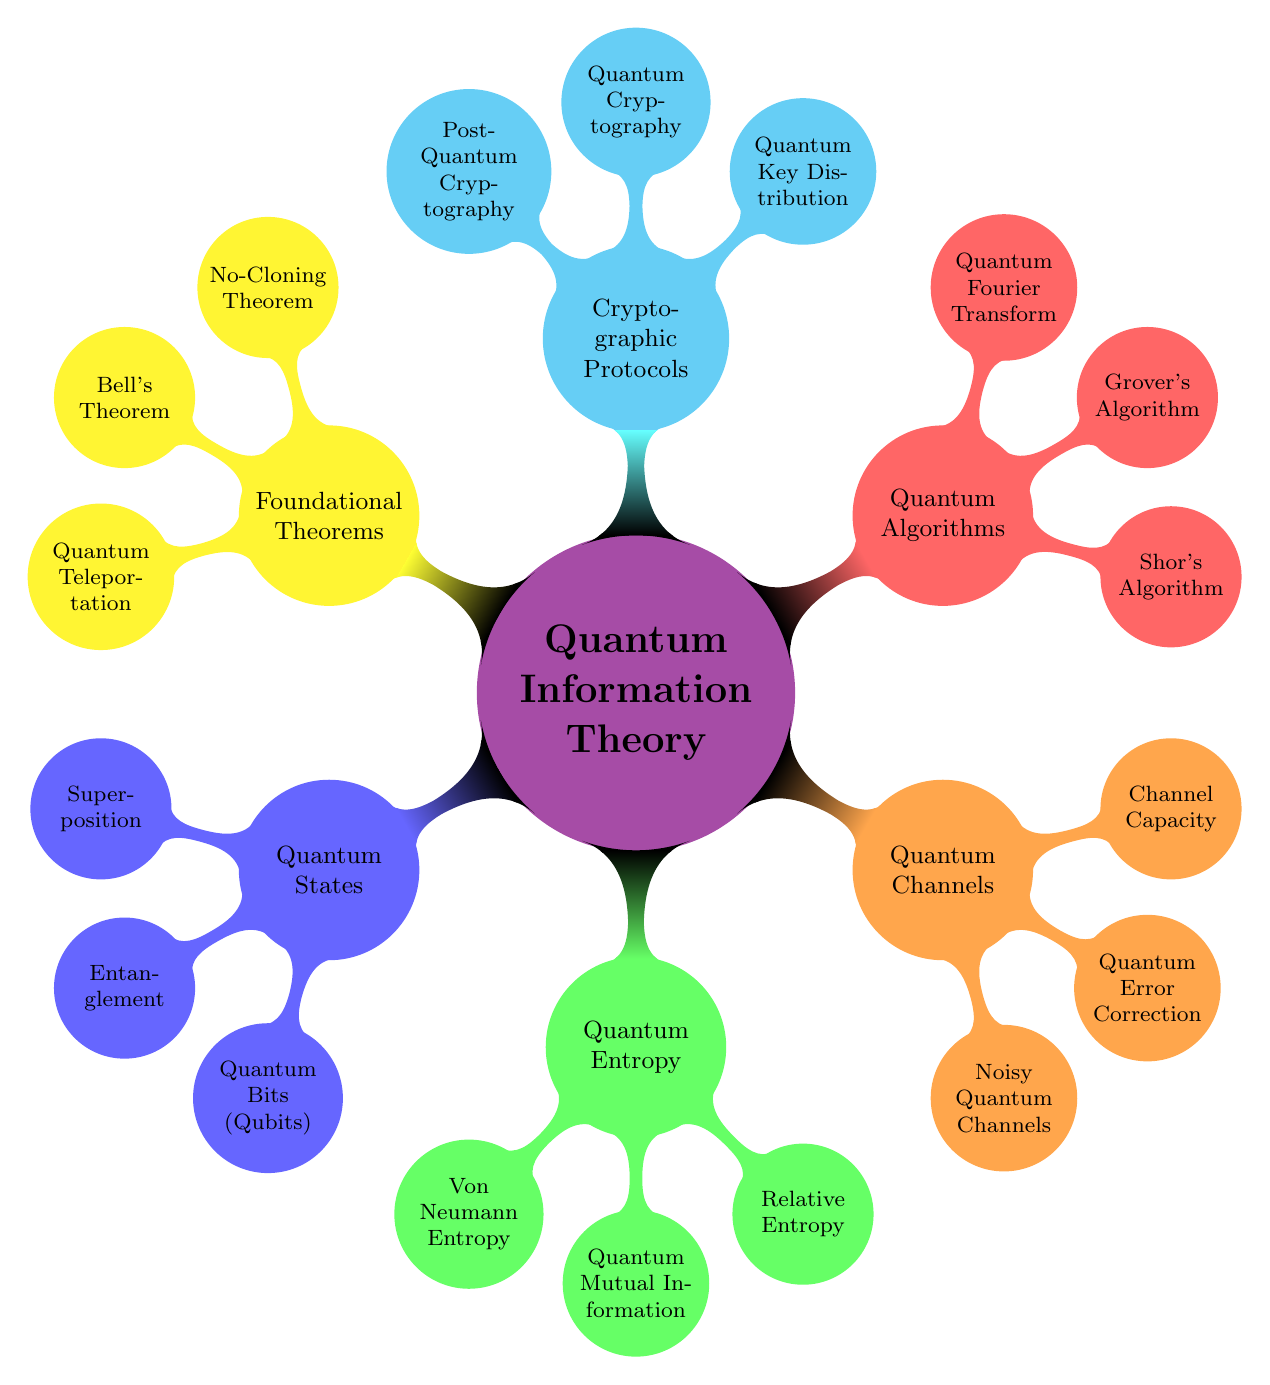What is the main topic of the diagram? The main topic is clearly labeled at the top center of the diagram, which is "Quantum Information Theory".
Answer: Quantum Information Theory How many child nodes does the "Quantum Algorithms" node have? By counting the immediate children of the "Quantum Algorithms" node, we see there are three: "Shor's Algorithm", "Grover's Algorithm", and "Quantum Fourier Transform".
Answer: 3 Which node is a part of both Quantum Channels and Quantum Algorithms? The analysis of the nodes shows that none of them are directly part of both categories; they are distinct, and each node is unique to its category.
Answer: None What concept is at the same hierarchy level as "Quantum Entropy"? By looking at the structure of the mind map, the nodes at the same level as "Quantum Entropy" are "Quantum States", "Quantum Channels", "Quantum Algorithms", "Cryptographic Protocols", and "Foundational Theorems".
Answer: Quantum States, Quantum Channels, Quantum Algorithms, Cryptographic Protocols, Foundational Theorems Which foundational theorem deals with the impossibility of copying quantum states? Among the foundational theorems listed, the "No-Cloning Theorem" specifically addresses the impossibility of perfectly copying quantum states.
Answer: No-Cloning Theorem What is the relationship between "Quantum Key Distribution" and "Quantum Cryptography"? Both are under the "Cryptographic Protocols" category, indicating they are closely related concepts in quantum security, with "Quantum Key Distribution" being a specific type of "Quantum Cryptography".
Answer: Related concepts How many total nodes are present in the diagram? To calculate the total number of nodes, we sum the main node and all its children across the diagram. The total is: 1 (main) + 3 (Quantum States) + 3 (Quantum Entropy) + 3 (Quantum Channels) + 3 (Quantum Algorithms) + 3 (Cryptographic Protocols) + 3 (Foundational Theorems) = 16 nodes.
Answer: 16 Which algorithm is specifically designed for factoring large numbers? Identifying the specific algorithms listed, "Shor's Algorithm" is the one designed for factoring large numbers efficiently using quantum computing.
Answer: Shor's Algorithm Which node would you find "Quantum Error Correction" under? By tracing the structure of the diagram, "Quantum Error Correction" is directly listed as a child under the "Quantum Channels" node.
Answer: Quantum Channels 